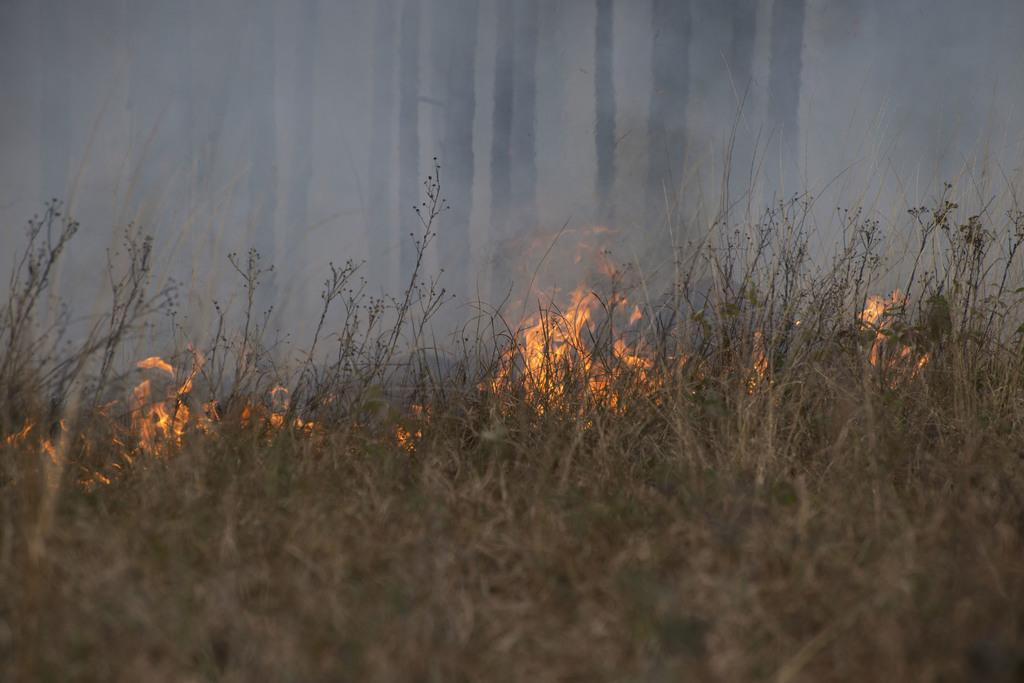What is happening to the grass in the image? There is fire on the surface of the grass in the image. What can be seen in the background of the image? There are trees in the background of the image. What type of nut is being cracked during the recess in the image? There is no recess or nut present in the image; it features fire on the grass and trees in the background. 